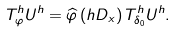<formula> <loc_0><loc_0><loc_500><loc_500>T _ { \varphi } ^ { h } U ^ { h } = \widehat { \varphi } \left ( h D _ { x } \right ) T _ { \delta _ { 0 } } ^ { h } U ^ { h } .</formula> 